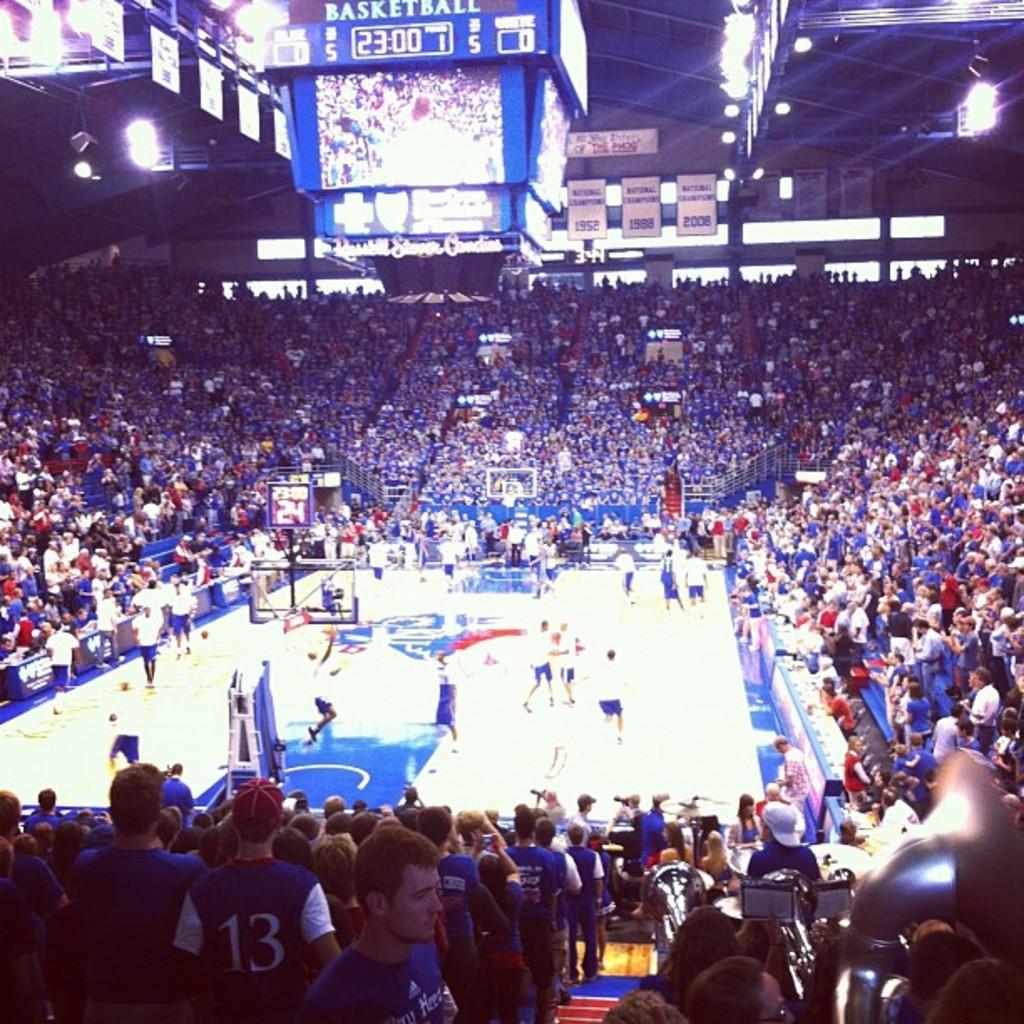Could you give a brief overview of what you see in this image? In the center of the image there are people playing a game. There are people standing in the stadium. In the background of the image there are lights, boards, display boards. There is a screen. 